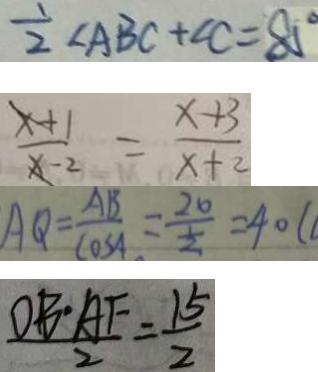<formula> <loc_0><loc_0><loc_500><loc_500>\frac { 1 } { 2 } \angle A B C + \angle C = 8 5 ^ { \circ } 
 \frac { x + 1 } { x - 2 } = \frac { x + 3 } { x + 2 } 
 A Q = \frac { A B } { \cos A } = \frac { 2 0 } { \frac { 1 } { 2 } } = 4 0 ( 
 \frac { D B \cdot A F } { 2 } = \frac { 1 5 } { 2 }</formula> 